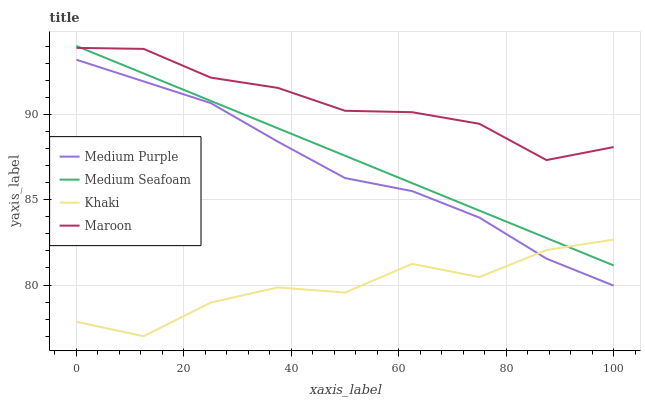Does Khaki have the minimum area under the curve?
Answer yes or no. Yes. Does Maroon have the maximum area under the curve?
Answer yes or no. Yes. Does Medium Seafoam have the minimum area under the curve?
Answer yes or no. No. Does Medium Seafoam have the maximum area under the curve?
Answer yes or no. No. Is Medium Seafoam the smoothest?
Answer yes or no. Yes. Is Khaki the roughest?
Answer yes or no. Yes. Is Khaki the smoothest?
Answer yes or no. No. Is Medium Seafoam the roughest?
Answer yes or no. No. Does Khaki have the lowest value?
Answer yes or no. Yes. Does Medium Seafoam have the lowest value?
Answer yes or no. No. Does Medium Seafoam have the highest value?
Answer yes or no. Yes. Does Khaki have the highest value?
Answer yes or no. No. Is Medium Purple less than Maroon?
Answer yes or no. Yes. Is Maroon greater than Medium Purple?
Answer yes or no. Yes. Does Maroon intersect Medium Seafoam?
Answer yes or no. Yes. Is Maroon less than Medium Seafoam?
Answer yes or no. No. Is Maroon greater than Medium Seafoam?
Answer yes or no. No. Does Medium Purple intersect Maroon?
Answer yes or no. No. 